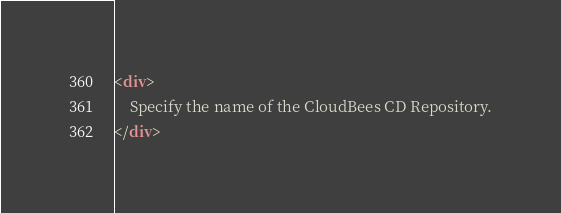<code> <loc_0><loc_0><loc_500><loc_500><_HTML_><div>
    Specify the name of the CloudBees CD Repository.
</div>
</code> 